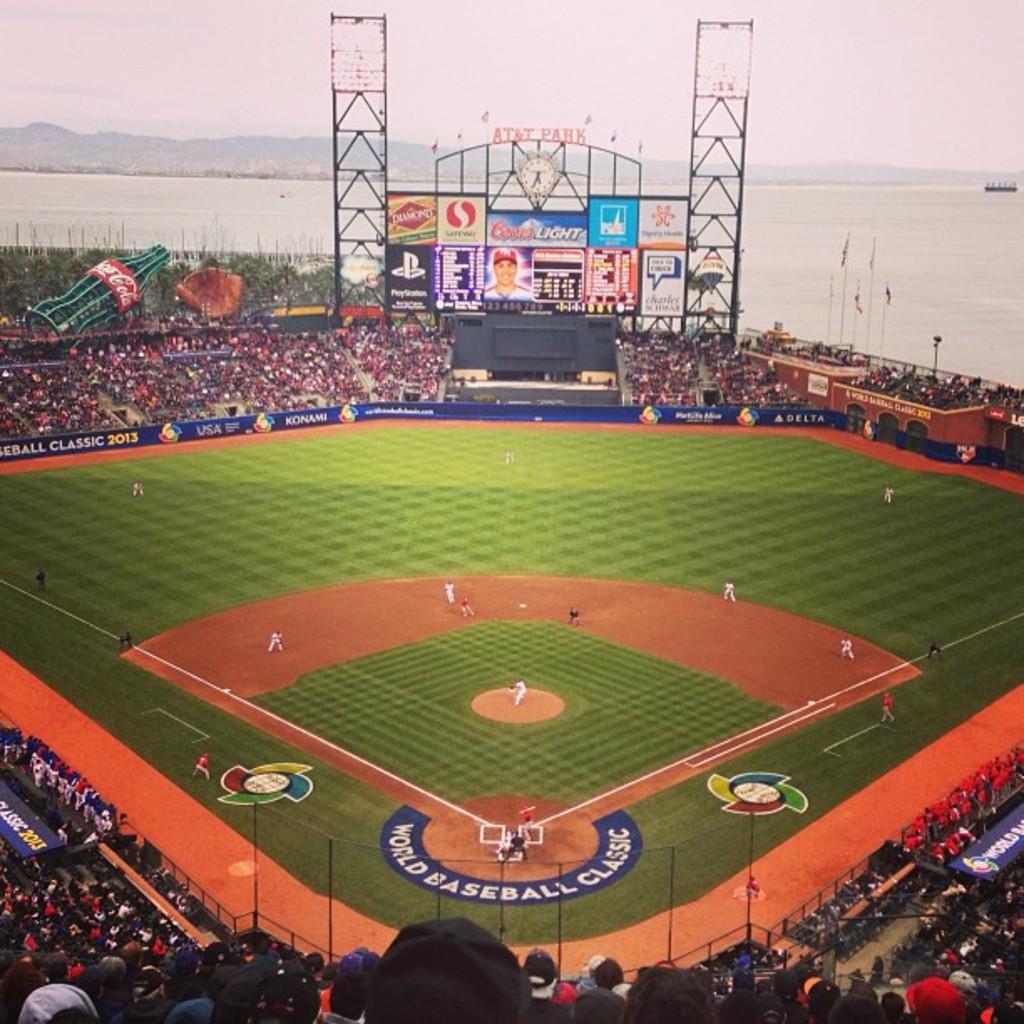What does it say around home base?
Your answer should be very brief. World baseball classic. What does the text in the blue semi circle at the bottom middle of the picture say?
Provide a short and direct response. World baseball classic. 